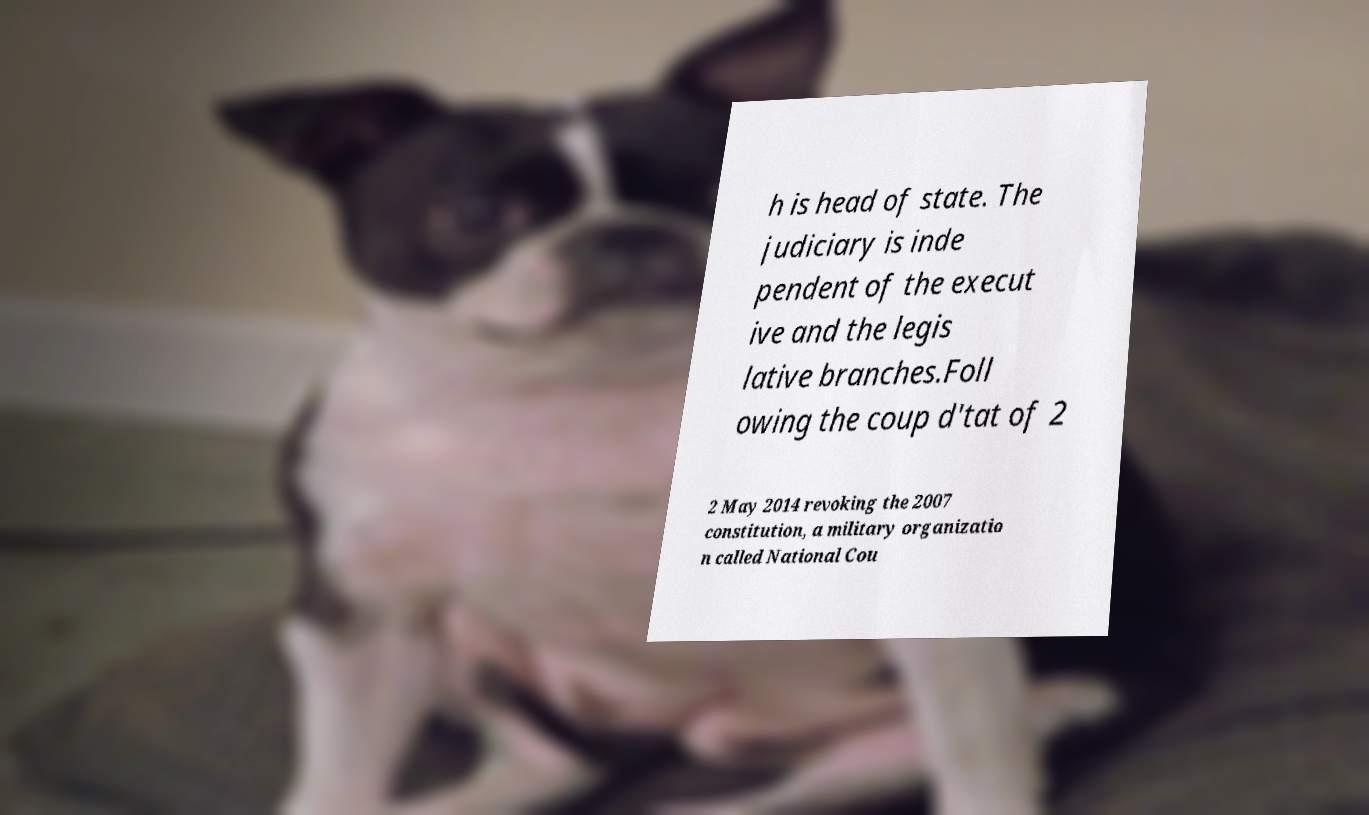For documentation purposes, I need the text within this image transcribed. Could you provide that? h is head of state. The judiciary is inde pendent of the execut ive and the legis lative branches.Foll owing the coup d'tat of 2 2 May 2014 revoking the 2007 constitution, a military organizatio n called National Cou 